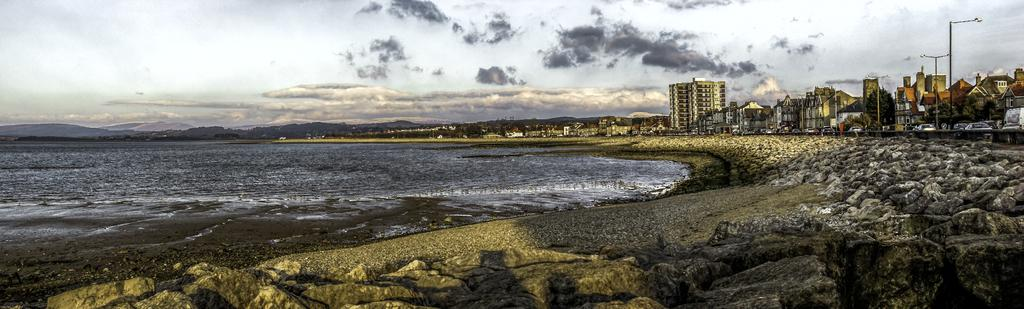What structures are located on the right side of the image? There are buildings and poles on the right side of the image. What natural feature is on the left side of the image? There is a river on the left side of the image. What can be seen in the distance in the image? There are mountains in the background of the image. What is visible in the sky in the image? The sky is visible in the background of the image. Where is the mine located in the image? There is no mine present in the image. What date is marked on the calendar in the image? There is no calendar present in the image. 